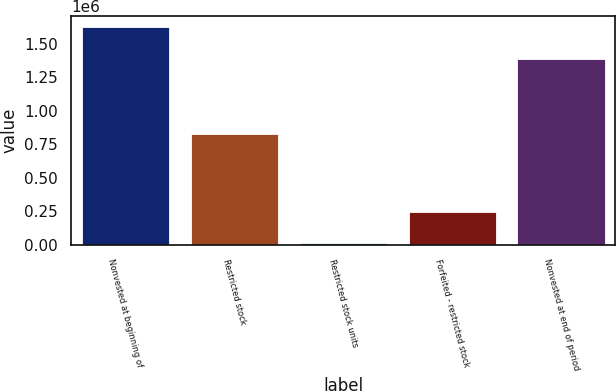Convert chart to OTSL. <chart><loc_0><loc_0><loc_500><loc_500><bar_chart><fcel>Nonvested at beginning of<fcel>Restricted stock<fcel>Restricted stock units<fcel>Forfeited - restricted stock<fcel>Nonvested at end of period<nl><fcel>1.62493e+06<fcel>826075<fcel>15338<fcel>245504<fcel>1.3876e+06<nl></chart> 